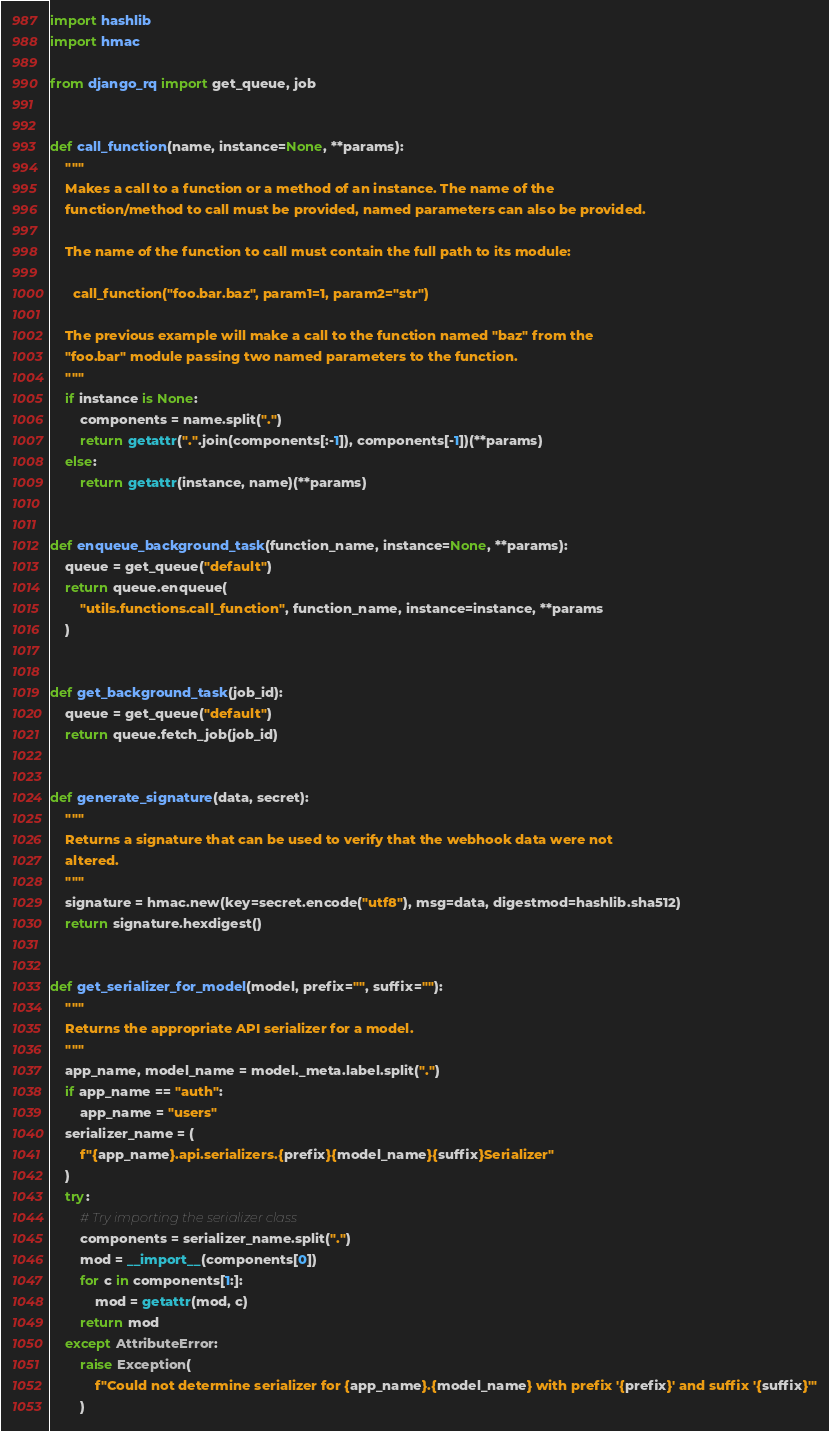Convert code to text. <code><loc_0><loc_0><loc_500><loc_500><_Python_>import hashlib
import hmac

from django_rq import get_queue, job


def call_function(name, instance=None, **params):
    """
    Makes a call to a function or a method of an instance. The name of the
    function/method to call must be provided, named parameters can also be provided.

    The name of the function to call must contain the full path to its module:

      call_function("foo.bar.baz", param1=1, param2="str")

    The previous example will make a call to the function named "baz" from the
    "foo.bar" module passing two named parameters to the function.
    """
    if instance is None:
        components = name.split(".")
        return getattr(".".join(components[:-1]), components[-1])(**params)
    else:
        return getattr(instance, name)(**params)


def enqueue_background_task(function_name, instance=None, **params):
    queue = get_queue("default")
    return queue.enqueue(
        "utils.functions.call_function", function_name, instance=instance, **params
    )


def get_background_task(job_id):
    queue = get_queue("default")
    return queue.fetch_job(job_id)


def generate_signature(data, secret):
    """
    Returns a signature that can be used to verify that the webhook data were not
    altered.
    """
    signature = hmac.new(key=secret.encode("utf8"), msg=data, digestmod=hashlib.sha512)
    return signature.hexdigest()


def get_serializer_for_model(model, prefix="", suffix=""):
    """
    Returns the appropriate API serializer for a model.
    """
    app_name, model_name = model._meta.label.split(".")
    if app_name == "auth":
        app_name = "users"
    serializer_name = (
        f"{app_name}.api.serializers.{prefix}{model_name}{suffix}Serializer"
    )
    try:
        # Try importing the serializer class
        components = serializer_name.split(".")
        mod = __import__(components[0])
        for c in components[1:]:
            mod = getattr(mod, c)
        return mod
    except AttributeError:
        raise Exception(
            f"Could not determine serializer for {app_name}.{model_name} with prefix '{prefix}' and suffix '{suffix}'"
        )
</code> 